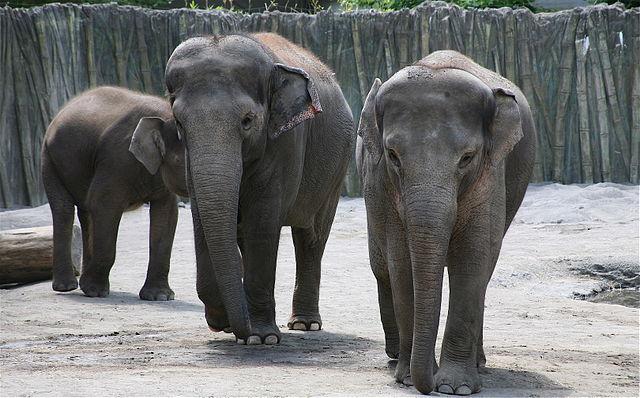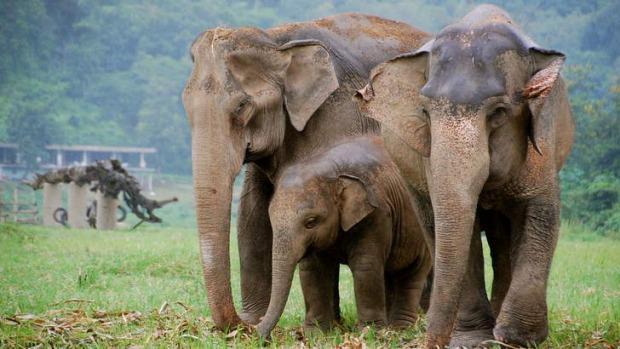The first image is the image on the left, the second image is the image on the right. Evaluate the accuracy of this statement regarding the images: "There is at least two elephants in the right image.". Is it true? Answer yes or no. Yes. The first image is the image on the left, the second image is the image on the right. Given the left and right images, does the statement "Every image shows exactly one elephant that is outdoors." hold true? Answer yes or no. No. 